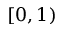<formula> <loc_0><loc_0><loc_500><loc_500>[ 0 , 1 )</formula> 